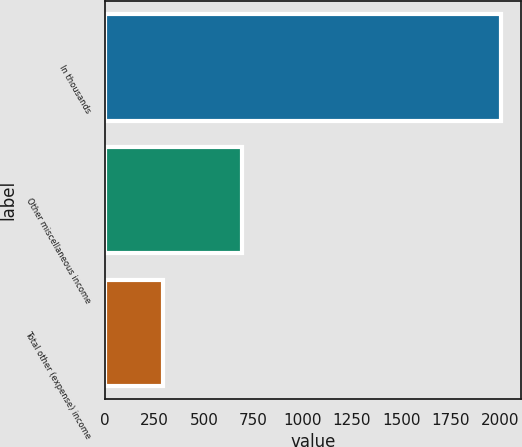<chart> <loc_0><loc_0><loc_500><loc_500><bar_chart><fcel>In thousands<fcel>Other miscellaneous income<fcel>Total other (expense) income<nl><fcel>2008<fcel>691<fcel>292<nl></chart> 